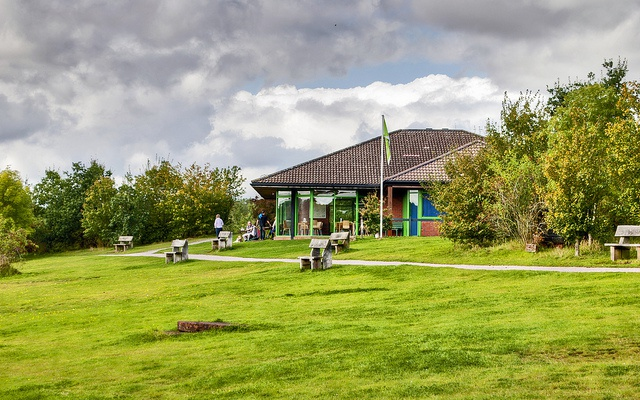Describe the objects in this image and their specific colors. I can see bench in lightgray, black, gray, and darkgray tones, bench in lightgray, tan, black, and darkgray tones, bench in lightgray, gray, darkgreen, and darkgray tones, bench in lightgray, olive, black, and tan tones, and bench in lightgray, darkgray, darkgreen, and black tones in this image. 